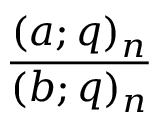Convert formula to latex. <formula><loc_0><loc_0><loc_500><loc_500>\frac { ( a ; q ) _ { n } } { ( b ; q ) _ { n } }</formula> 